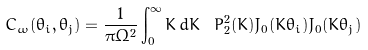<formula> <loc_0><loc_0><loc_500><loc_500>C _ { \omega } ( \theta _ { i } , \theta _ { j } ) = \frac { 1 } { \pi \Omega ^ { 2 } } \int _ { 0 } ^ { \infty } K \, d K \ P ^ { 2 } _ { 2 } ( K ) J _ { 0 } ( K \theta _ { i } ) J _ { 0 } ( K \theta _ { j } )</formula> 